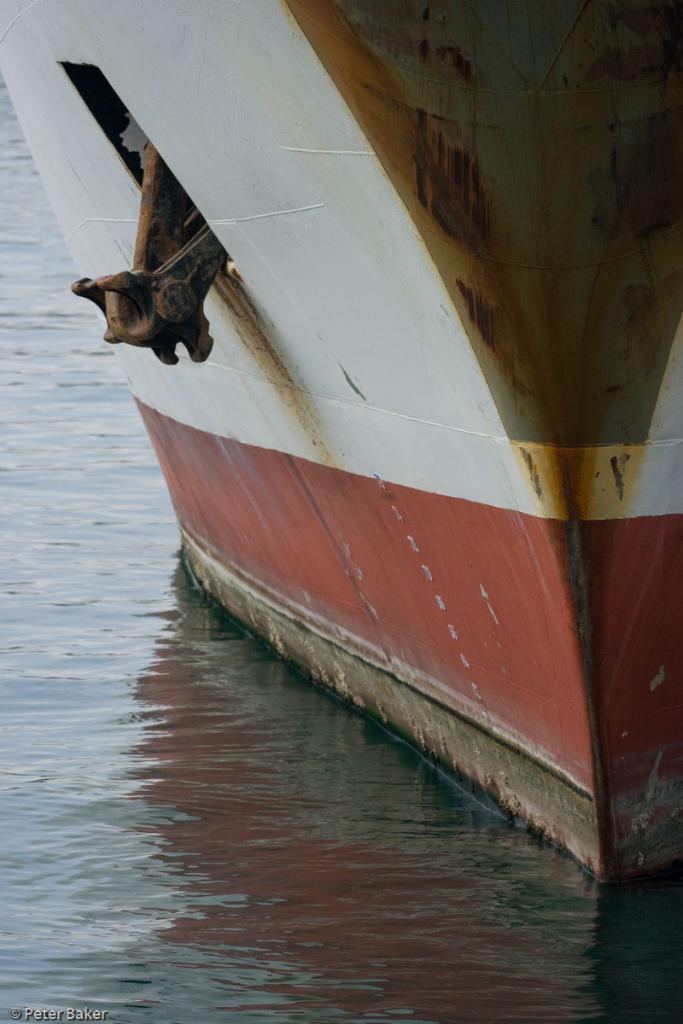What is the main subject of the image? The main subject of the image is a boat. Where is the boat located? The boat is on the water. Can you describe any additional features of the image? There is a watermark in the bottom left side of the image. What year is depicted in the image? There is no specific year depicted in the image; it only shows a boat on the water. Can you see any land in the image? The image only shows a boat on the water, so there is no land visible. 